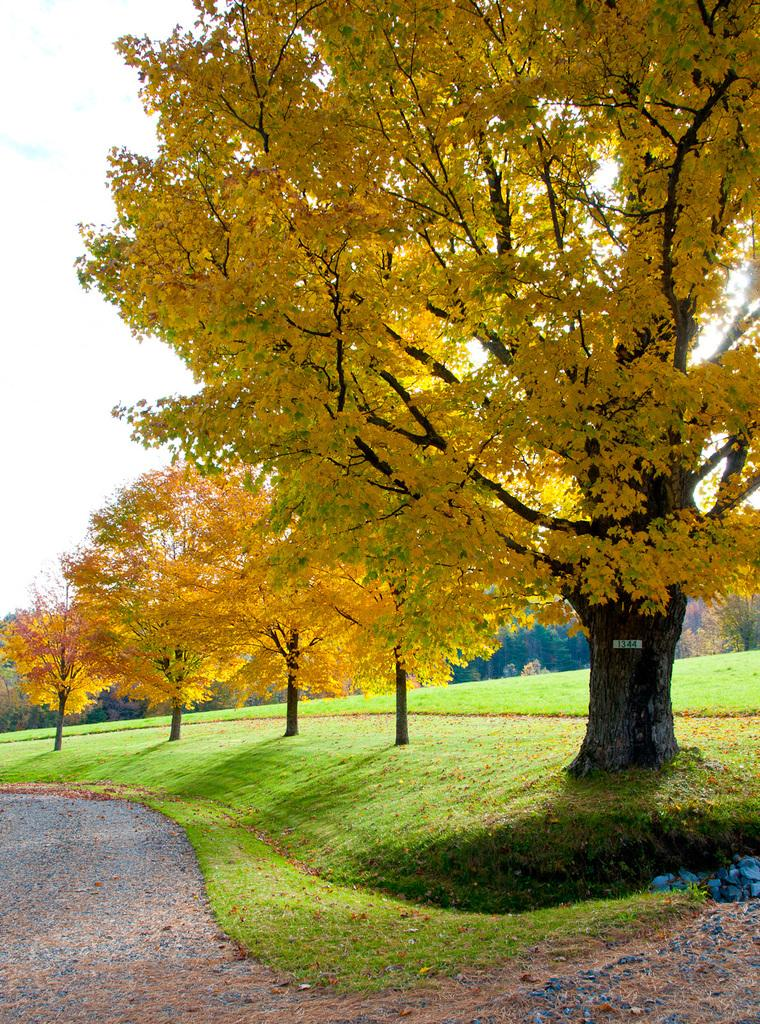What is the main feature in the foreground of the image? There is a road in the image. How is the road positioned in relation to the other elements in the image? The road is in front of the other elements in the image. What type of vegetation is on the right side of the image? There is grass on the right side of the image. Can you describe the surface of the grass? The grass is on the surface. What can be seen in the background of the image? There are trees and the sky visible in the background of the image. What type of vacation is being advertised on the shelf in the image? There is no shelf or vacation advertisement present in the image. 